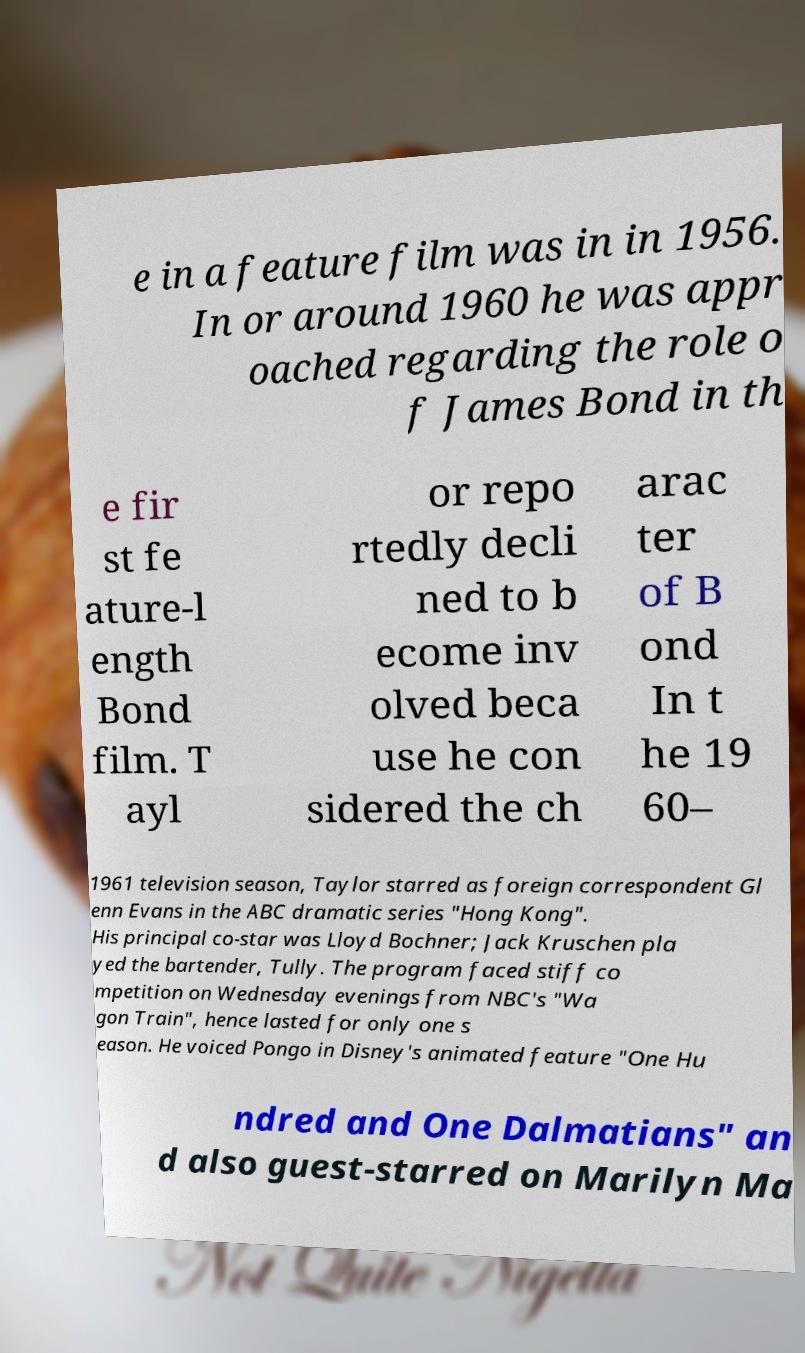Please identify and transcribe the text found in this image. e in a feature film was in in 1956. In or around 1960 he was appr oached regarding the role o f James Bond in th e fir st fe ature-l ength Bond film. T ayl or repo rtedly decli ned to b ecome inv olved beca use he con sidered the ch arac ter of B ond In t he 19 60– 1961 television season, Taylor starred as foreign correspondent Gl enn Evans in the ABC dramatic series "Hong Kong". His principal co-star was Lloyd Bochner; Jack Kruschen pla yed the bartender, Tully. The program faced stiff co mpetition on Wednesday evenings from NBC's "Wa gon Train", hence lasted for only one s eason. He voiced Pongo in Disney's animated feature "One Hu ndred and One Dalmatians" an d also guest-starred on Marilyn Ma 